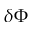Convert formula to latex. <formula><loc_0><loc_0><loc_500><loc_500>\delta \Phi</formula> 